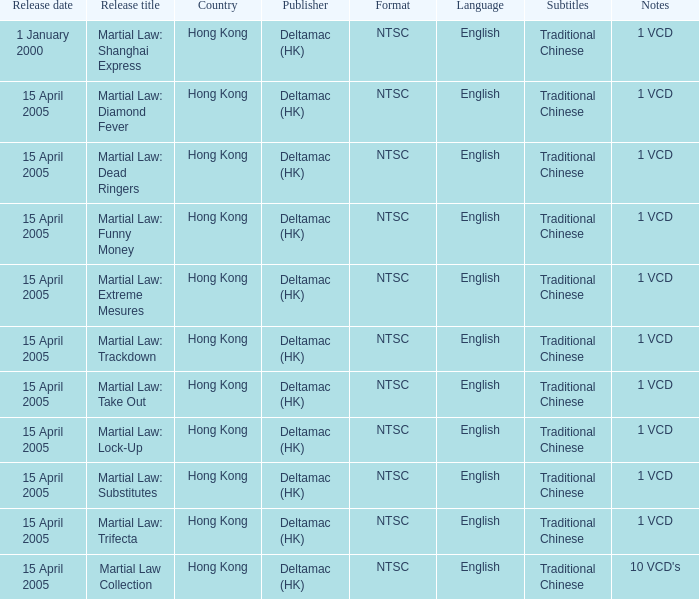What is the release date of Martial Law: Take Out? 15 April 2005. 